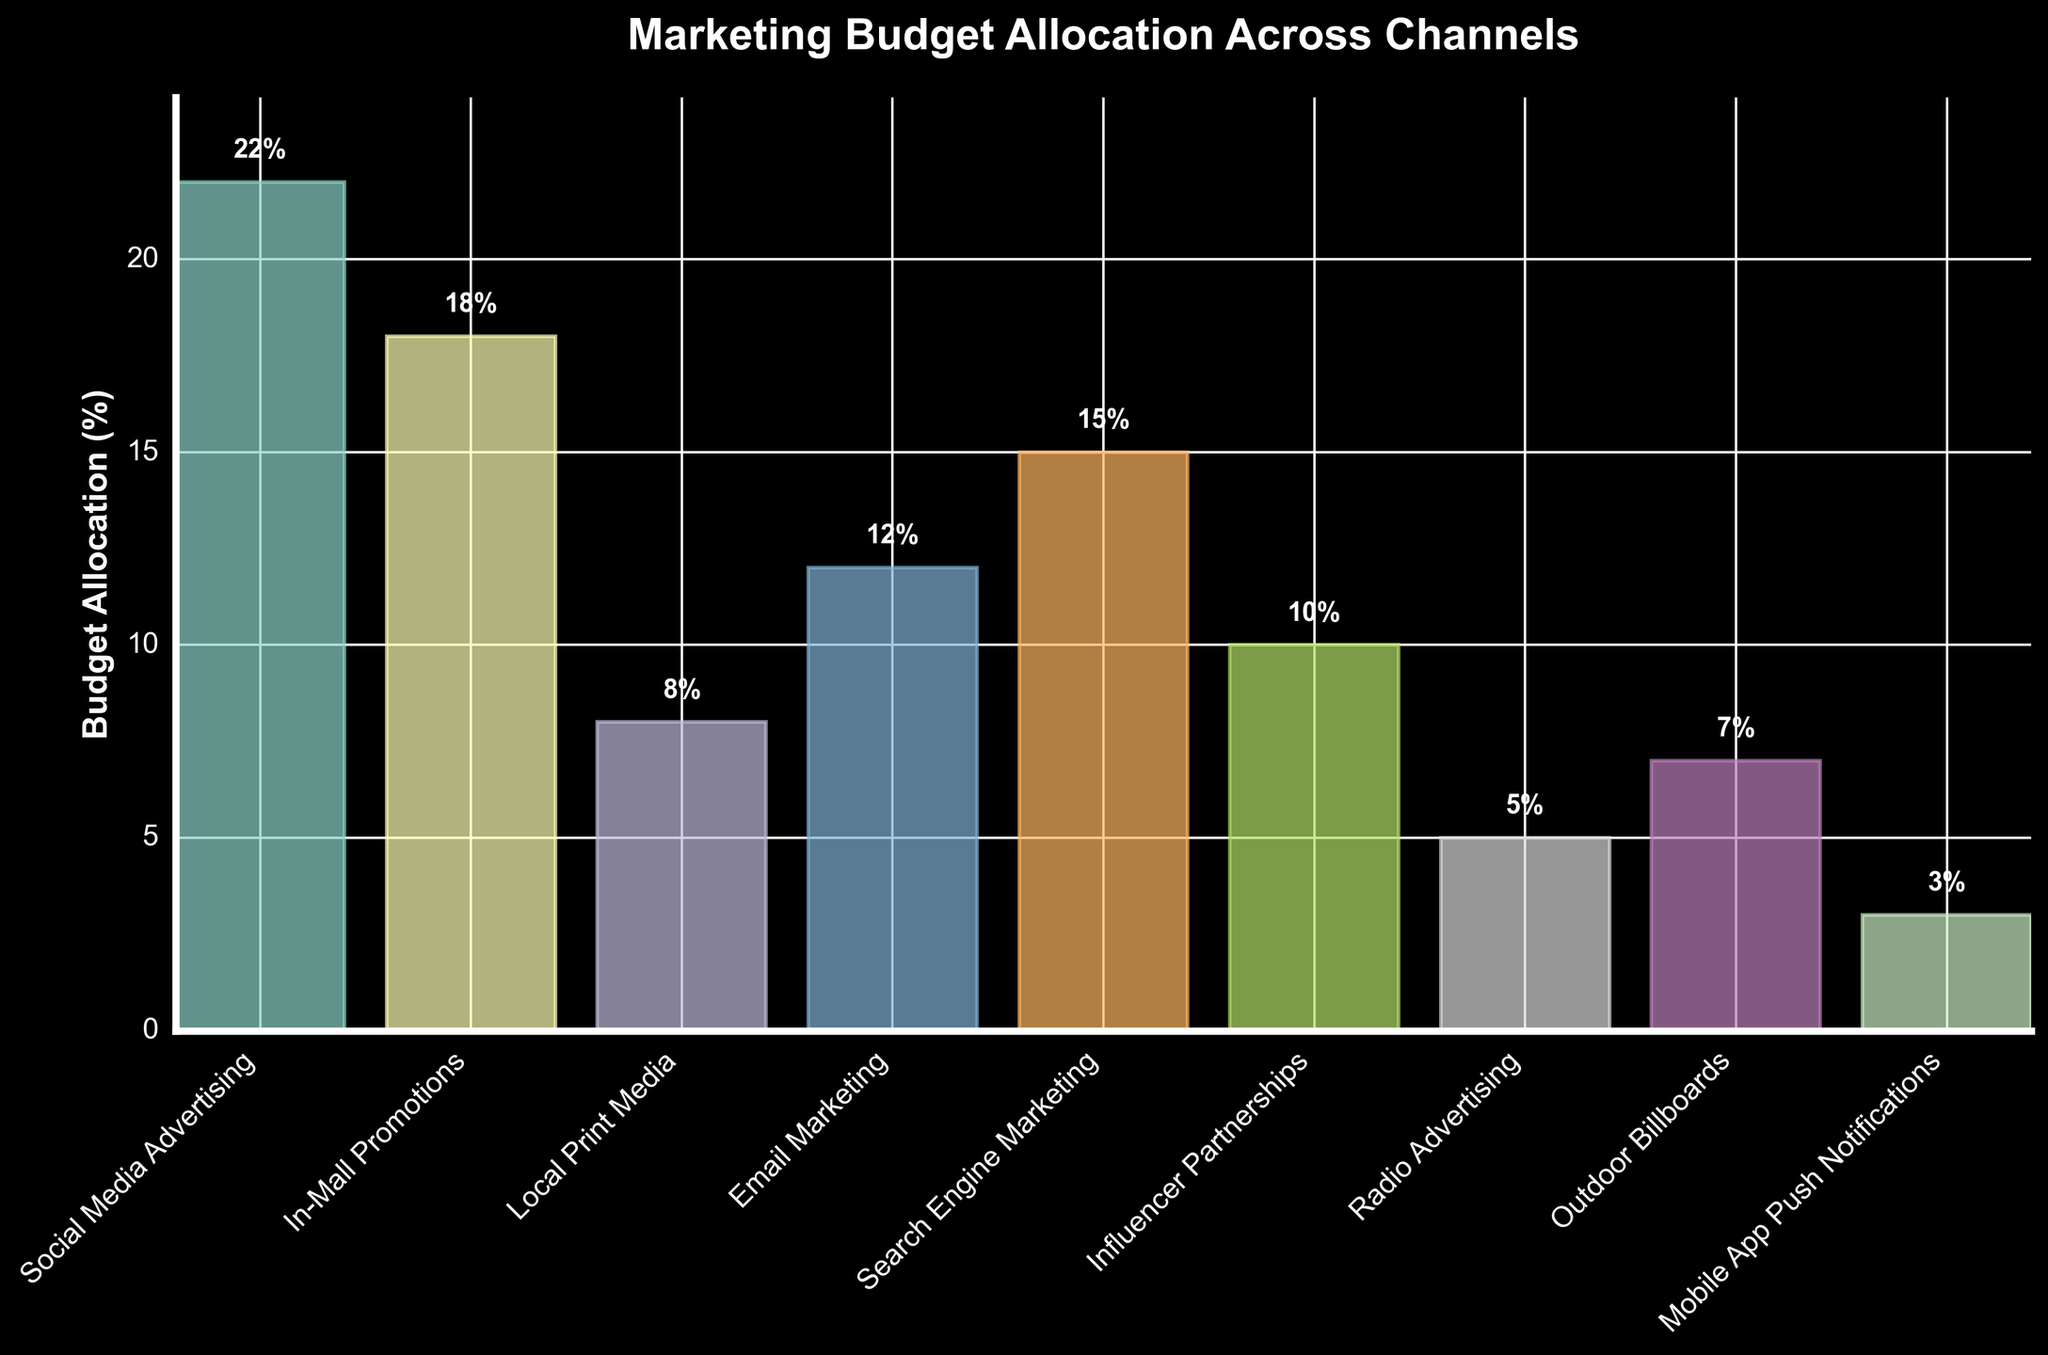Which channel has the highest budget allocation? By looking at the heights of the bars, the tallest one represents the channel with the highest budget allocation. Social Media Advertising has the highest bar.
Answer: Social Media Advertising What are the three channels with the lowest budget allocation, and what's their combined percentage? Identify the three shortest bars: Radio Advertising (5%), Outdoor Billboards (7%), and Mobile App Push Notifications (3%). Adding them gives 5% + 7% + 3% = 15%.
Answer: Radio Advertising, Outdoor Billboards, and Mobile App Push Notifications, 15% Which channel has a budget allocation greater than Email Marketing but less than Search Engine Marketing? Find Email Marketing (12%) and Search Engine Marketing (15%), then identify the channel in between. Influencer Partnerships is between them with 10%.
Answer: Influencer Partnerships How much more budget percentage is allocated to Social Media Advertising compared to Local Print Media? Social Media Advertising has 22%, and Local Print Media has 8%. The difference is 22% - 8% = 14%.
Answer: 14% What's the average budget allocation percentage across all channels? Sum all the percentages and divide by the number of channels: (22 + 18 + 8 + 12 + 15 + 10 + 5 + 7 + 3) / 9 = 11.11%.
Answer: 11.11% If the total budget is $100,000, how much money is allocated to In-Mall Promotions? In-Mall Promotions has 18%. The amount can be calculated as (18/100) * $100,000 = $18,000.
Answer: $18,000 Are there more channels with budget allocations above or below 10%? Identify channels above 10%: Social Media Advertising (22%), In-Mall Promotions (18%), Email Marketing (12%), Search Engine Marketing (15%) which are 4. Below 10% are: Local Print Media (8%), Influencer Partnerships (10%), Radio Advertising (5%), Outdoor Billboards (7%), Mobile App Push Notifications (3%) which are 5.
Answer: Below 10% Which two channels combined equal the budget allocation of Social Media Advertising? Social Media Advertising has 22%. Two channels, In-Mall Promotions (18%) and Mobile App Push Notifications (3%) together give 21%, close but not equal. Email Marketing (12%) and Search Engine Marketing (15%) sum up to 12% + 15% = 27%, invalid. The closest pairs are Email Marketing (12%) and Local Print Media (8%), combined they are 12% + 8% = 20% which is also invalid. Due to constraints, there is no exact match.
Answer: None What is the ratio of budget allocation between Radio Advertising and Search Engine Marketing? Radio Advertising is 5% and Search Engine Marketing is 15%. The ratio is 5:15 which simplifies to 1:3.
Answer: 1:3 